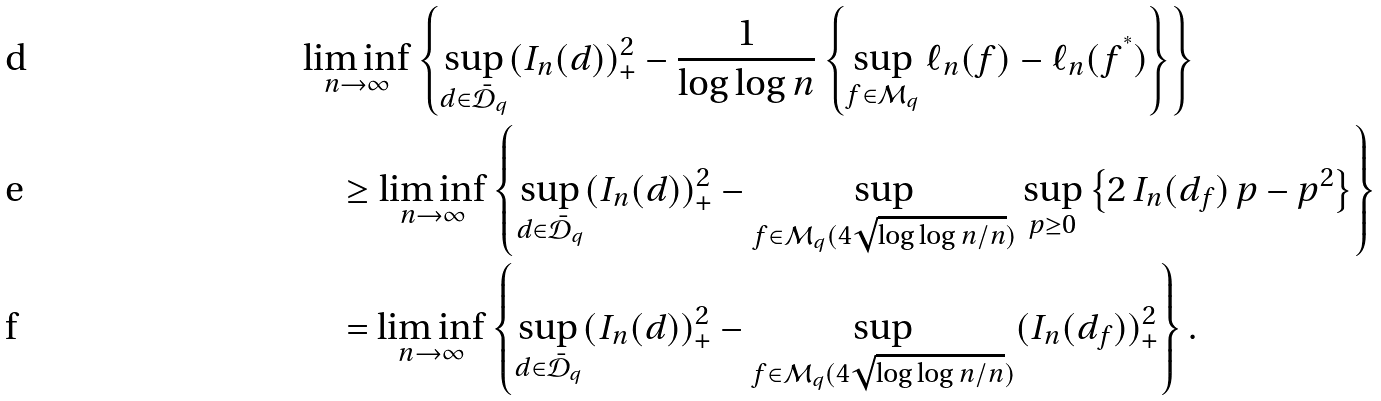<formula> <loc_0><loc_0><loc_500><loc_500>& \liminf _ { n \to \infty } \left \{ \sup _ { d \in \mathcal { \bar { D } } _ { q } } ( I _ { n } ( d ) ) _ { + } ^ { 2 } - \frac { 1 } { \log \log n } \left \{ \sup _ { f \in \mathcal { M } _ { q } } \ell _ { n } ( f ) - \ell _ { n } ( f ^ { ^ { * } } ) \right \} \right \} \\ & \quad \geq \liminf _ { n \to \infty } \left \{ \sup _ { d \in \mathcal { \bar { D } } _ { q } } ( I _ { n } ( d ) ) _ { + } ^ { 2 } - \sup _ { f \in \mathcal { M } _ { q } ( 4 \sqrt { \log \log n / n } ) } \sup _ { p \geq 0 } \left \{ 2 \, I _ { n } ( d _ { f } ) \, p - p ^ { 2 } \right \} \right \} \\ & \quad = \liminf _ { n \to \infty } \left \{ \sup _ { d \in \mathcal { \bar { D } } _ { q } } ( I _ { n } ( d ) ) _ { + } ^ { 2 } - \sup _ { f \in \mathcal { M } _ { q } ( 4 \sqrt { \log \log n / n } ) } ( I _ { n } ( d _ { f } ) ) _ { + } ^ { 2 } \right \} .</formula> 